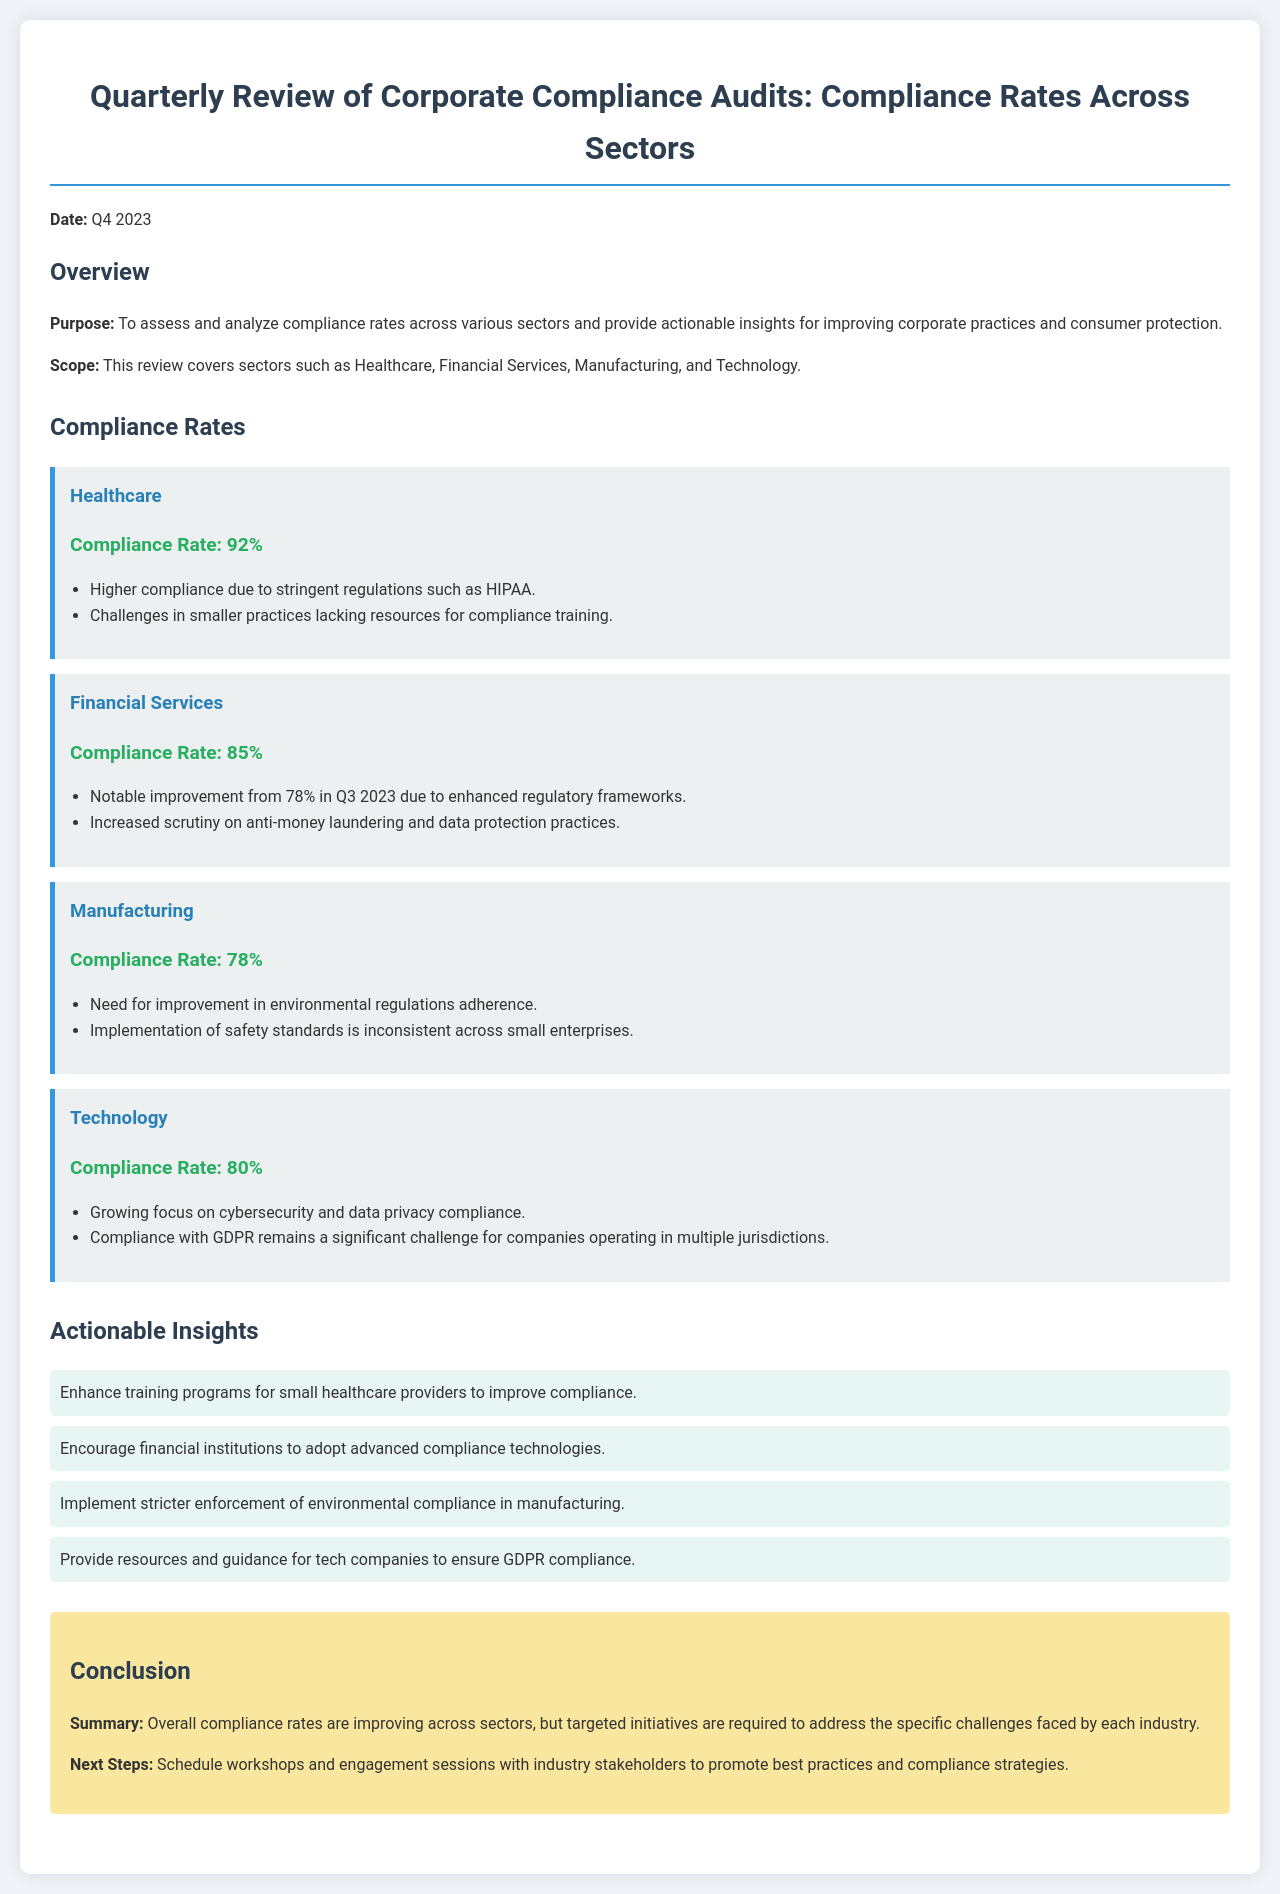What is the compliance rate for Healthcare? The compliance rate for Healthcare is explicitly mentioned in the document as 92%.
Answer: 92% What is the notable improvement in the compliance rate for Financial Services from Q3 2023? The document states that the compliance rate improved to 85% from 78% in Q3 2023.
Answer: 7% What sector has the lowest compliance rate? The document lists the compliance rates, with Manufacturing having the lowest rate at 78%.
Answer: Manufacturing What challenge is mentioned for smaller healthcare practices? The document indicates challenges in smaller practices due to lack of resources for compliance training.
Answer: Lack of resources for compliance training What is one actionable insight for the Financial Services sector? The document suggests that financial institutions should adopt advanced compliance technologies as an actionable insight.
Answer: Adopt advanced compliance technologies What is the purpose of this Quarterly Review? The document describes the purpose as assessing and analyzing compliance rates across various sectors to improve corporate practices.
Answer: Assess and analyze compliance rates What specific compliance challenge do technology companies face? The document highlights that complying with GDPR remains a significant challenge for companies operating in multiple jurisdictions.
Answer: GDPR compliance challenge What is the compliance rate for the Technology sector? The compliance rate for the Technology sector is stated as 80%.
Answer: 80% 